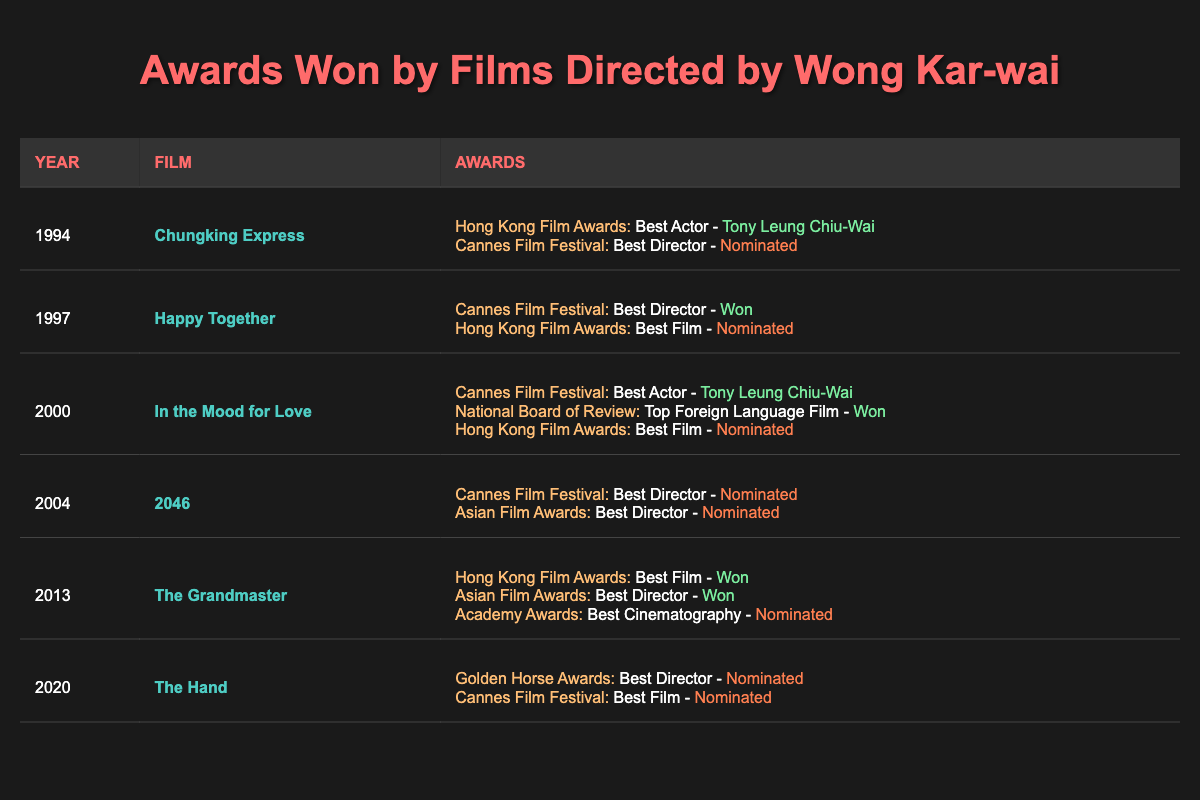What film directed by Wong Kar-wai won an award at the Hong Kong Film Awards? The table shows that "The Grandmaster," released in 2013, won the Best Film award at the Hong Kong Film Awards.
Answer: The Grandmaster How many films directed by Wong Kar-wai were nominated for the Best Director category at Cannes? The films "Chungking Express," "Happy Together," "In the Mood for Love," "2046," and "The Hand" were all considered for the Best Director category at Cannes, but only "Happy Together" won. Therefore, there were four nominations and one win.
Answer: Four nominations Which film received the most awards overall? By analyzing the table, "The Grandmaster" received the highest number of awards, winning two and receiving one nomination, totaling three awards.
Answer: The Grandmaster Did "In the Mood for Love" win any awards? Yes, "In the Mood for Love" won the Best Actor award at the Cannes Film Festival for Tony Leung Chiu-Wai and received a win at the National Board of Review for Top Foreign Language Film.
Answer: Yes What is the common outcome for Wong Kar-wai's films in the Hong Kong Film Awards? Most of Wong Kar-wai's films listed in the table received nominations for the Hong Kong Film Awards, with only "The Grandmaster" winning the award.
Answer: Nominated Which year saw Wong Kar-wai winning the Cannes Film Festival Best Director award? The film "Happy Together," directed by Wong Kar-wai, won the Best Director award at the Cannes Film Festival in 1997.
Answer: 1997 What is the trend regarding nominations and wins for Wong Kar-wai’s films in major festivals? The table shows a trend that while some films are frequently nominated, wins are less common, with "The Grandmaster" being a notable exception in 2013, indicating that nominations do not always result in wins.
Answer: Nominations are frequent, wins are rare How many times did Tony Leung Chiu-Wai win an award for his performances in Wong Kar-wai's films listed? According to the table, Tony Leung Chiu-Wai won the Best Actor award twice, once for "Chungking Express" and once for "In the Mood for Love."
Answer: Two times Which film directed by Wong Kar-wai had the most nominations without a win? "2046" had two nominations at major festivals (Cannes and Asian Film Awards) without winning any awards, making it the film with the most nominations without a win.
Answer: 2046 Is it true that all films by Wong Kar-wai in the table won at least one award? No, it is not true. "The Hand" and "2046" were both nominated but did not win any awards.
Answer: No 